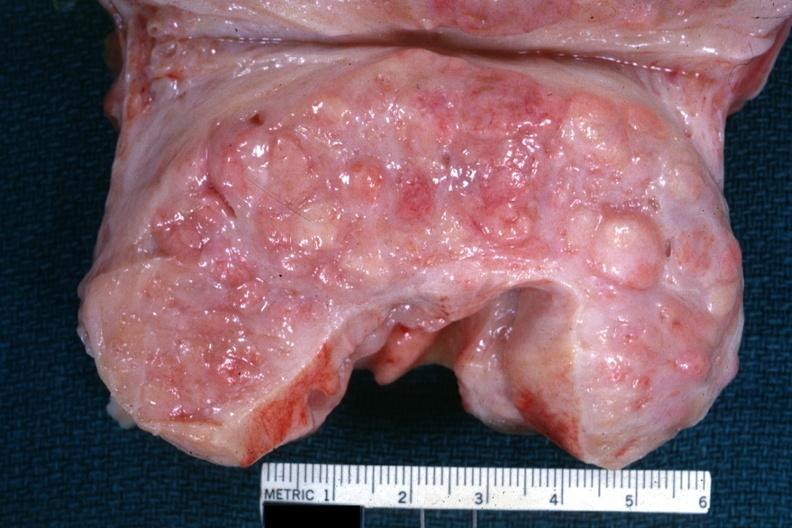what is present?
Answer the question using a single word or phrase. Prostate 